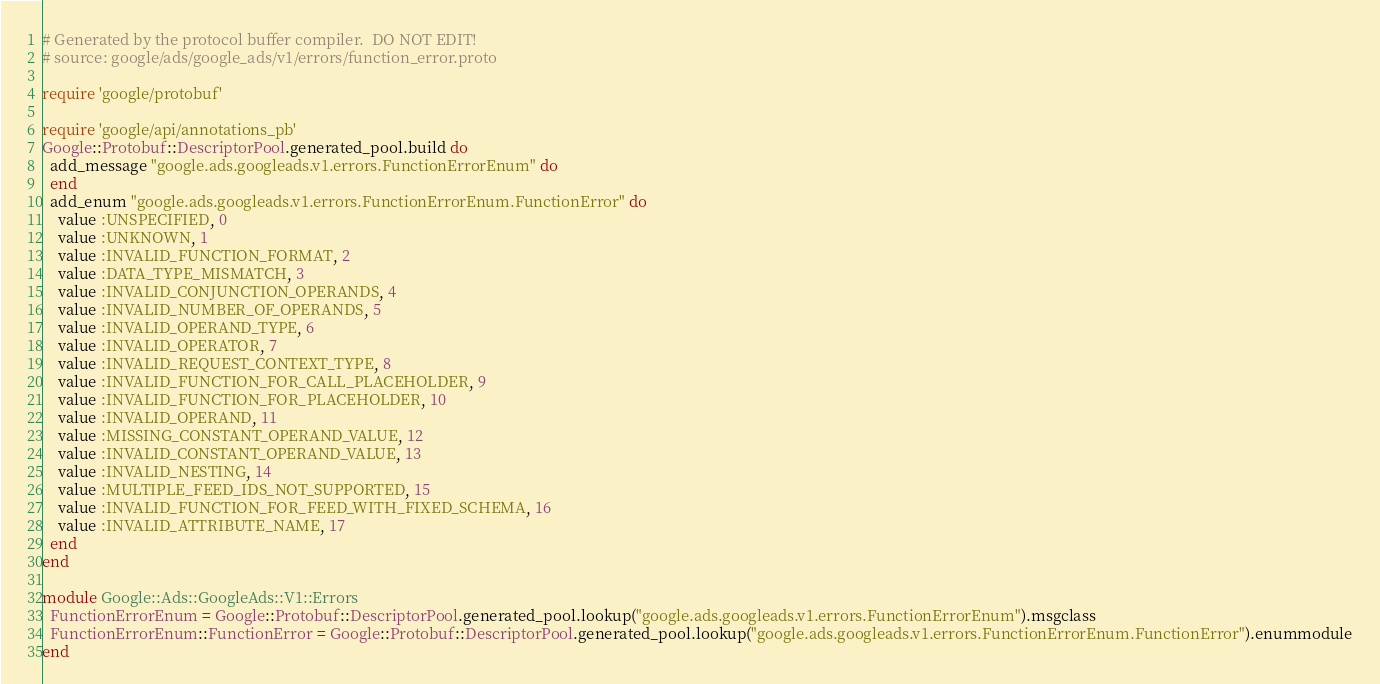<code> <loc_0><loc_0><loc_500><loc_500><_Ruby_># Generated by the protocol buffer compiler.  DO NOT EDIT!
# source: google/ads/google_ads/v1/errors/function_error.proto

require 'google/protobuf'

require 'google/api/annotations_pb'
Google::Protobuf::DescriptorPool.generated_pool.build do
  add_message "google.ads.googleads.v1.errors.FunctionErrorEnum" do
  end
  add_enum "google.ads.googleads.v1.errors.FunctionErrorEnum.FunctionError" do
    value :UNSPECIFIED, 0
    value :UNKNOWN, 1
    value :INVALID_FUNCTION_FORMAT, 2
    value :DATA_TYPE_MISMATCH, 3
    value :INVALID_CONJUNCTION_OPERANDS, 4
    value :INVALID_NUMBER_OF_OPERANDS, 5
    value :INVALID_OPERAND_TYPE, 6
    value :INVALID_OPERATOR, 7
    value :INVALID_REQUEST_CONTEXT_TYPE, 8
    value :INVALID_FUNCTION_FOR_CALL_PLACEHOLDER, 9
    value :INVALID_FUNCTION_FOR_PLACEHOLDER, 10
    value :INVALID_OPERAND, 11
    value :MISSING_CONSTANT_OPERAND_VALUE, 12
    value :INVALID_CONSTANT_OPERAND_VALUE, 13
    value :INVALID_NESTING, 14
    value :MULTIPLE_FEED_IDS_NOT_SUPPORTED, 15
    value :INVALID_FUNCTION_FOR_FEED_WITH_FIXED_SCHEMA, 16
    value :INVALID_ATTRIBUTE_NAME, 17
  end
end

module Google::Ads::GoogleAds::V1::Errors
  FunctionErrorEnum = Google::Protobuf::DescriptorPool.generated_pool.lookup("google.ads.googleads.v1.errors.FunctionErrorEnum").msgclass
  FunctionErrorEnum::FunctionError = Google::Protobuf::DescriptorPool.generated_pool.lookup("google.ads.googleads.v1.errors.FunctionErrorEnum.FunctionError").enummodule
end
</code> 